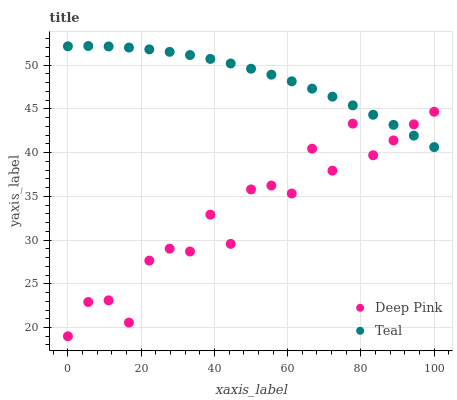Does Deep Pink have the minimum area under the curve?
Answer yes or no. Yes. Does Teal have the maximum area under the curve?
Answer yes or no. Yes. Does Teal have the minimum area under the curve?
Answer yes or no. No. Is Teal the smoothest?
Answer yes or no. Yes. Is Deep Pink the roughest?
Answer yes or no. Yes. Is Teal the roughest?
Answer yes or no. No. Does Deep Pink have the lowest value?
Answer yes or no. Yes. Does Teal have the lowest value?
Answer yes or no. No. Does Teal have the highest value?
Answer yes or no. Yes. Does Deep Pink intersect Teal?
Answer yes or no. Yes. Is Deep Pink less than Teal?
Answer yes or no. No. Is Deep Pink greater than Teal?
Answer yes or no. No. 